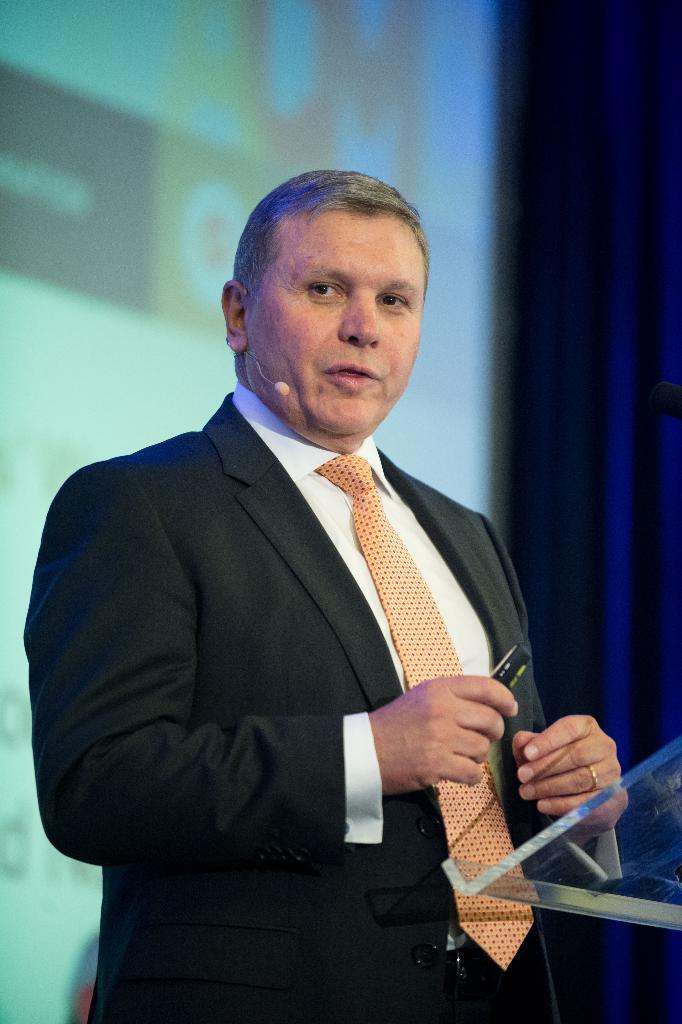What is the main subject of the image? There is a person in the image. Can you describe the person's attire? The person is wearing a suit. What is the person holding in the image? The person is holding an object. How would you describe the background of the image? The background of the image is blurry. What can be seen on the screen in the image? Unfortunately, the facts provided do not give any information about the screen's content. What type of parent can be seen holding a knife in the image? There is no parent or knife present in the image. 